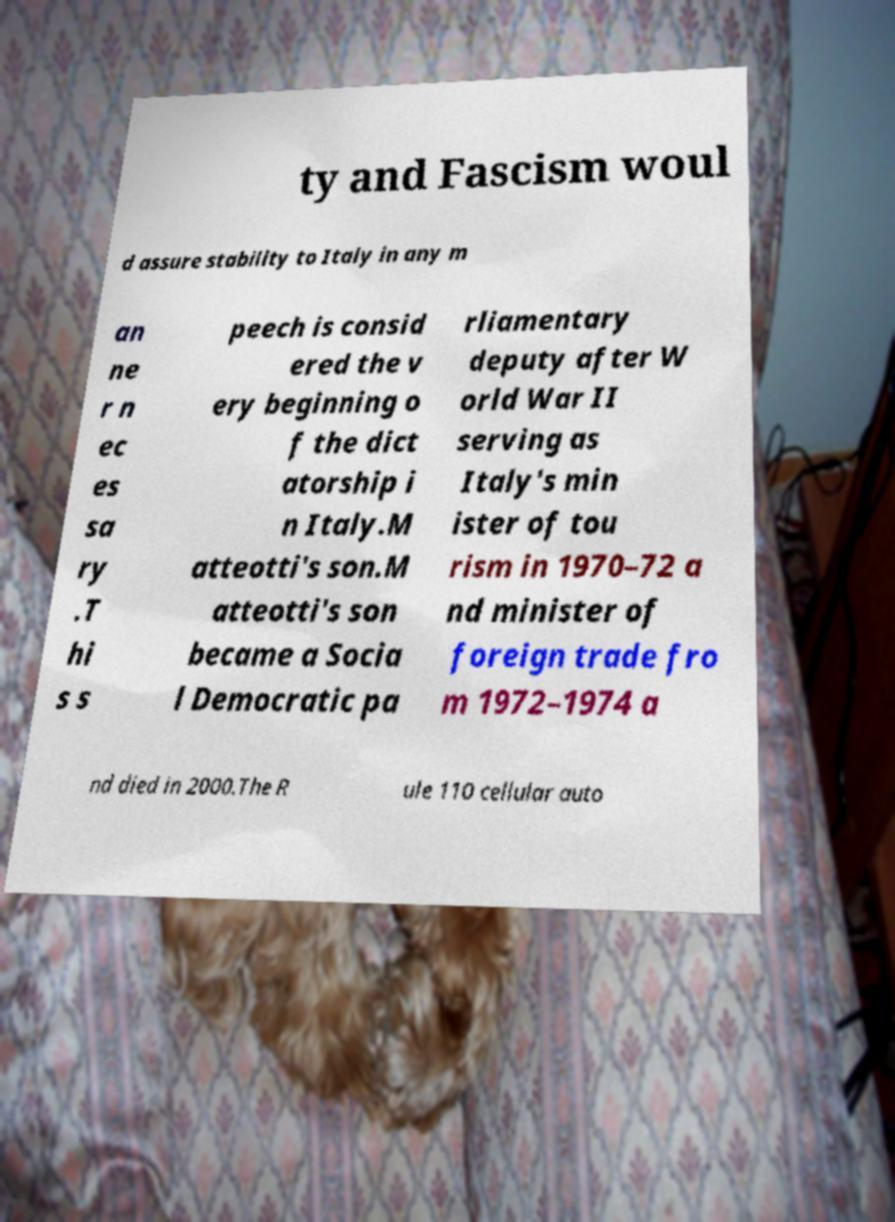What messages or text are displayed in this image? I need them in a readable, typed format. ty and Fascism woul d assure stability to Italy in any m an ne r n ec es sa ry .T hi s s peech is consid ered the v ery beginning o f the dict atorship i n Italy.M atteotti's son.M atteotti's son became a Socia l Democratic pa rliamentary deputy after W orld War II serving as Italy's min ister of tou rism in 1970–72 a nd minister of foreign trade fro m 1972–1974 a nd died in 2000.The R ule 110 cellular auto 